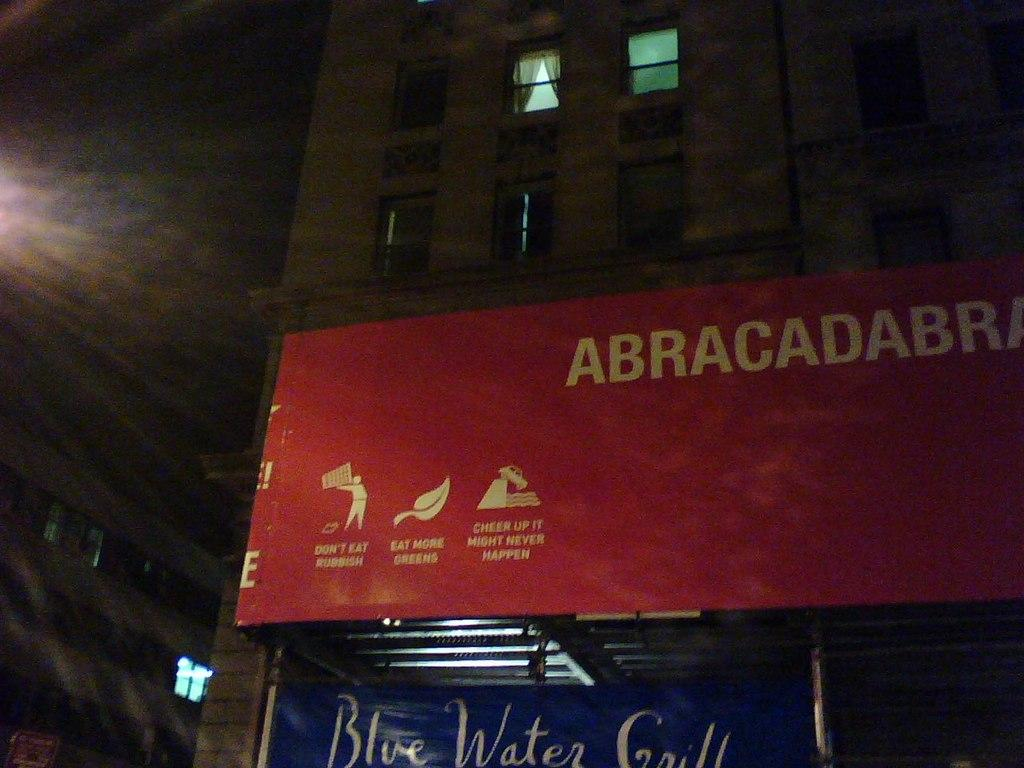<image>
Give a short and clear explanation of the subsequent image. A red sign says not to eat rubbish in white lettering towards the bottom. 